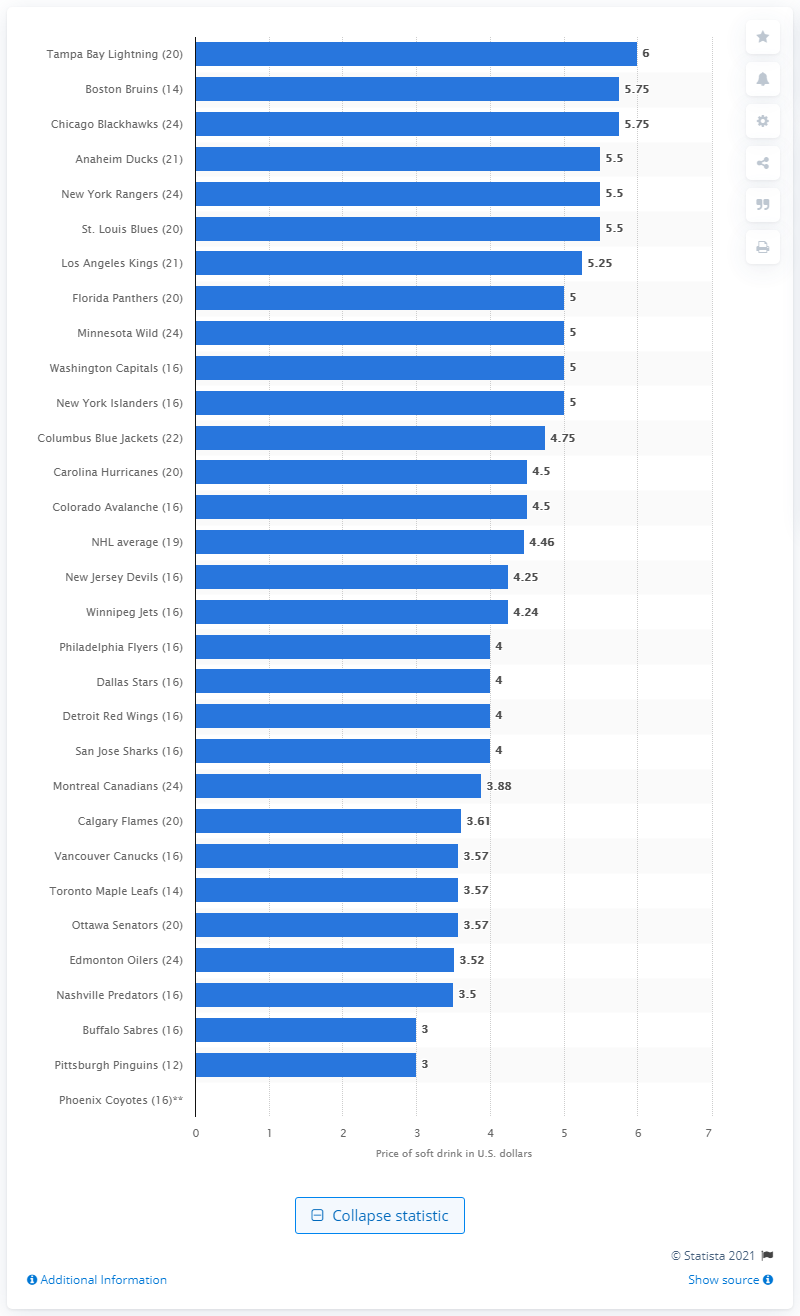Identify some key points in this picture. In the 2014/15 season, small soft drinks sold for an average of 4.25 per transaction at New Jersey Devils games. 